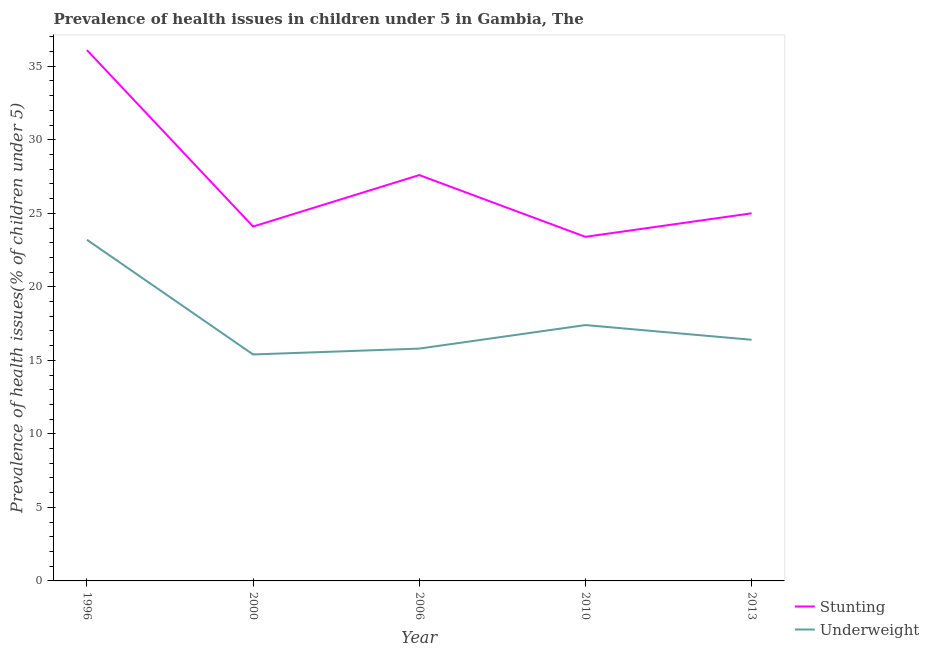Is the number of lines equal to the number of legend labels?
Your answer should be compact. Yes. What is the percentage of underweight children in 2000?
Give a very brief answer. 15.4. Across all years, what is the maximum percentage of underweight children?
Your answer should be compact. 23.2. Across all years, what is the minimum percentage of stunted children?
Provide a succinct answer. 23.4. In which year was the percentage of stunted children maximum?
Offer a very short reply. 1996. In which year was the percentage of underweight children minimum?
Provide a short and direct response. 2000. What is the total percentage of stunted children in the graph?
Your answer should be very brief. 136.2. What is the difference between the percentage of stunted children in 2010 and that in 2013?
Make the answer very short. -1.6. What is the difference between the percentage of underweight children in 2006 and the percentage of stunted children in 2013?
Provide a short and direct response. -9.2. What is the average percentage of stunted children per year?
Ensure brevity in your answer.  27.24. In the year 1996, what is the difference between the percentage of underweight children and percentage of stunted children?
Offer a terse response. -12.9. In how many years, is the percentage of stunted children greater than 12 %?
Your answer should be very brief. 5. What is the ratio of the percentage of stunted children in 2000 to that in 2013?
Offer a very short reply. 0.96. What is the difference between the highest and the second highest percentage of underweight children?
Make the answer very short. 5.8. What is the difference between the highest and the lowest percentage of stunted children?
Make the answer very short. 12.7. In how many years, is the percentage of underweight children greater than the average percentage of underweight children taken over all years?
Provide a short and direct response. 1. Is the sum of the percentage of underweight children in 2010 and 2013 greater than the maximum percentage of stunted children across all years?
Provide a short and direct response. No. Does the percentage of stunted children monotonically increase over the years?
Provide a short and direct response. No. Is the percentage of underweight children strictly less than the percentage of stunted children over the years?
Your answer should be very brief. Yes. How many lines are there?
Provide a succinct answer. 2. How many years are there in the graph?
Provide a succinct answer. 5. What is the difference between two consecutive major ticks on the Y-axis?
Give a very brief answer. 5. Where does the legend appear in the graph?
Keep it short and to the point. Bottom right. How are the legend labels stacked?
Your answer should be very brief. Vertical. What is the title of the graph?
Your response must be concise. Prevalence of health issues in children under 5 in Gambia, The. Does "Travel Items" appear as one of the legend labels in the graph?
Your response must be concise. No. What is the label or title of the Y-axis?
Offer a terse response. Prevalence of health issues(% of children under 5). What is the Prevalence of health issues(% of children under 5) of Stunting in 1996?
Your answer should be very brief. 36.1. What is the Prevalence of health issues(% of children under 5) of Underweight in 1996?
Your answer should be very brief. 23.2. What is the Prevalence of health issues(% of children under 5) in Stunting in 2000?
Provide a succinct answer. 24.1. What is the Prevalence of health issues(% of children under 5) in Underweight in 2000?
Provide a short and direct response. 15.4. What is the Prevalence of health issues(% of children under 5) in Stunting in 2006?
Offer a very short reply. 27.6. What is the Prevalence of health issues(% of children under 5) in Underweight in 2006?
Your answer should be compact. 15.8. What is the Prevalence of health issues(% of children under 5) of Stunting in 2010?
Your answer should be very brief. 23.4. What is the Prevalence of health issues(% of children under 5) of Underweight in 2010?
Offer a very short reply. 17.4. What is the Prevalence of health issues(% of children under 5) in Stunting in 2013?
Make the answer very short. 25. What is the Prevalence of health issues(% of children under 5) of Underweight in 2013?
Keep it short and to the point. 16.4. Across all years, what is the maximum Prevalence of health issues(% of children under 5) in Stunting?
Provide a short and direct response. 36.1. Across all years, what is the maximum Prevalence of health issues(% of children under 5) in Underweight?
Offer a terse response. 23.2. Across all years, what is the minimum Prevalence of health issues(% of children under 5) of Stunting?
Ensure brevity in your answer.  23.4. Across all years, what is the minimum Prevalence of health issues(% of children under 5) in Underweight?
Keep it short and to the point. 15.4. What is the total Prevalence of health issues(% of children under 5) in Stunting in the graph?
Ensure brevity in your answer.  136.2. What is the total Prevalence of health issues(% of children under 5) of Underweight in the graph?
Your response must be concise. 88.2. What is the difference between the Prevalence of health issues(% of children under 5) of Underweight in 1996 and that in 2000?
Your answer should be very brief. 7.8. What is the difference between the Prevalence of health issues(% of children under 5) of Underweight in 1996 and that in 2010?
Offer a terse response. 5.8. What is the difference between the Prevalence of health issues(% of children under 5) in Stunting in 1996 and that in 2013?
Offer a very short reply. 11.1. What is the difference between the Prevalence of health issues(% of children under 5) of Underweight in 1996 and that in 2013?
Your answer should be very brief. 6.8. What is the difference between the Prevalence of health issues(% of children under 5) of Underweight in 2000 and that in 2006?
Offer a very short reply. -0.4. What is the difference between the Prevalence of health issues(% of children under 5) of Stunting in 2000 and that in 2010?
Provide a succinct answer. 0.7. What is the difference between the Prevalence of health issues(% of children under 5) of Underweight in 2000 and that in 2013?
Your answer should be very brief. -1. What is the difference between the Prevalence of health issues(% of children under 5) in Stunting in 2006 and that in 2010?
Provide a short and direct response. 4.2. What is the difference between the Prevalence of health issues(% of children under 5) in Stunting in 1996 and the Prevalence of health issues(% of children under 5) in Underweight in 2000?
Make the answer very short. 20.7. What is the difference between the Prevalence of health issues(% of children under 5) in Stunting in 1996 and the Prevalence of health issues(% of children under 5) in Underweight in 2006?
Keep it short and to the point. 20.3. What is the difference between the Prevalence of health issues(% of children under 5) in Stunting in 1996 and the Prevalence of health issues(% of children under 5) in Underweight in 2010?
Your answer should be very brief. 18.7. What is the difference between the Prevalence of health issues(% of children under 5) in Stunting in 1996 and the Prevalence of health issues(% of children under 5) in Underweight in 2013?
Offer a very short reply. 19.7. What is the difference between the Prevalence of health issues(% of children under 5) of Stunting in 2000 and the Prevalence of health issues(% of children under 5) of Underweight in 2010?
Ensure brevity in your answer.  6.7. What is the difference between the Prevalence of health issues(% of children under 5) of Stunting in 2000 and the Prevalence of health issues(% of children under 5) of Underweight in 2013?
Your answer should be compact. 7.7. What is the difference between the Prevalence of health issues(% of children under 5) of Stunting in 2010 and the Prevalence of health issues(% of children under 5) of Underweight in 2013?
Offer a terse response. 7. What is the average Prevalence of health issues(% of children under 5) in Stunting per year?
Ensure brevity in your answer.  27.24. What is the average Prevalence of health issues(% of children under 5) in Underweight per year?
Provide a succinct answer. 17.64. In the year 1996, what is the difference between the Prevalence of health issues(% of children under 5) of Stunting and Prevalence of health issues(% of children under 5) of Underweight?
Offer a terse response. 12.9. In the year 2006, what is the difference between the Prevalence of health issues(% of children under 5) of Stunting and Prevalence of health issues(% of children under 5) of Underweight?
Your answer should be very brief. 11.8. In the year 2010, what is the difference between the Prevalence of health issues(% of children under 5) in Stunting and Prevalence of health issues(% of children under 5) in Underweight?
Your answer should be compact. 6. What is the ratio of the Prevalence of health issues(% of children under 5) in Stunting in 1996 to that in 2000?
Offer a terse response. 1.5. What is the ratio of the Prevalence of health issues(% of children under 5) in Underweight in 1996 to that in 2000?
Ensure brevity in your answer.  1.51. What is the ratio of the Prevalence of health issues(% of children under 5) in Stunting in 1996 to that in 2006?
Make the answer very short. 1.31. What is the ratio of the Prevalence of health issues(% of children under 5) of Underweight in 1996 to that in 2006?
Make the answer very short. 1.47. What is the ratio of the Prevalence of health issues(% of children under 5) of Stunting in 1996 to that in 2010?
Give a very brief answer. 1.54. What is the ratio of the Prevalence of health issues(% of children under 5) in Underweight in 1996 to that in 2010?
Your response must be concise. 1.33. What is the ratio of the Prevalence of health issues(% of children under 5) in Stunting in 1996 to that in 2013?
Offer a terse response. 1.44. What is the ratio of the Prevalence of health issues(% of children under 5) in Underweight in 1996 to that in 2013?
Your answer should be compact. 1.41. What is the ratio of the Prevalence of health issues(% of children under 5) of Stunting in 2000 to that in 2006?
Offer a terse response. 0.87. What is the ratio of the Prevalence of health issues(% of children under 5) of Underweight in 2000 to that in 2006?
Provide a succinct answer. 0.97. What is the ratio of the Prevalence of health issues(% of children under 5) of Stunting in 2000 to that in 2010?
Offer a terse response. 1.03. What is the ratio of the Prevalence of health issues(% of children under 5) in Underweight in 2000 to that in 2010?
Offer a very short reply. 0.89. What is the ratio of the Prevalence of health issues(% of children under 5) of Stunting in 2000 to that in 2013?
Ensure brevity in your answer.  0.96. What is the ratio of the Prevalence of health issues(% of children under 5) in Underweight in 2000 to that in 2013?
Make the answer very short. 0.94. What is the ratio of the Prevalence of health issues(% of children under 5) of Stunting in 2006 to that in 2010?
Give a very brief answer. 1.18. What is the ratio of the Prevalence of health issues(% of children under 5) in Underweight in 2006 to that in 2010?
Provide a succinct answer. 0.91. What is the ratio of the Prevalence of health issues(% of children under 5) in Stunting in 2006 to that in 2013?
Offer a very short reply. 1.1. What is the ratio of the Prevalence of health issues(% of children under 5) in Underweight in 2006 to that in 2013?
Offer a very short reply. 0.96. What is the ratio of the Prevalence of health issues(% of children under 5) of Stunting in 2010 to that in 2013?
Keep it short and to the point. 0.94. What is the ratio of the Prevalence of health issues(% of children under 5) of Underweight in 2010 to that in 2013?
Offer a very short reply. 1.06. What is the difference between the highest and the second highest Prevalence of health issues(% of children under 5) in Stunting?
Provide a short and direct response. 8.5. What is the difference between the highest and the second highest Prevalence of health issues(% of children under 5) in Underweight?
Give a very brief answer. 5.8. What is the difference between the highest and the lowest Prevalence of health issues(% of children under 5) of Underweight?
Offer a terse response. 7.8. 